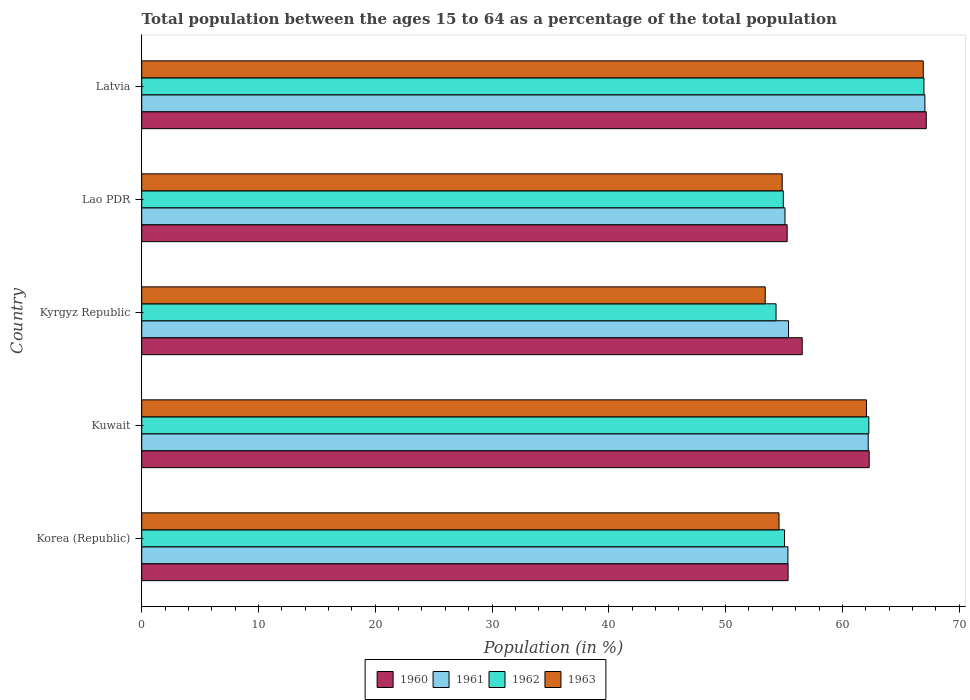How many groups of bars are there?
Provide a succinct answer. 5. How many bars are there on the 5th tick from the top?
Provide a short and direct response. 4. How many bars are there on the 5th tick from the bottom?
Offer a very short reply. 4. What is the label of the 1st group of bars from the top?
Keep it short and to the point. Latvia. In how many cases, is the number of bars for a given country not equal to the number of legend labels?
Your response must be concise. 0. What is the percentage of the population ages 15 to 64 in 1963 in Kuwait?
Provide a short and direct response. 62.06. Across all countries, what is the maximum percentage of the population ages 15 to 64 in 1960?
Ensure brevity in your answer.  67.18. Across all countries, what is the minimum percentage of the population ages 15 to 64 in 1960?
Your answer should be compact. 55.27. In which country was the percentage of the population ages 15 to 64 in 1960 maximum?
Give a very brief answer. Latvia. In which country was the percentage of the population ages 15 to 64 in 1962 minimum?
Provide a short and direct response. Kyrgyz Republic. What is the total percentage of the population ages 15 to 64 in 1961 in the graph?
Offer a terse response. 295.09. What is the difference between the percentage of the population ages 15 to 64 in 1962 in Korea (Republic) and that in Lao PDR?
Ensure brevity in your answer.  0.11. What is the difference between the percentage of the population ages 15 to 64 in 1960 in Lao PDR and the percentage of the population ages 15 to 64 in 1961 in Latvia?
Provide a short and direct response. -11.79. What is the average percentage of the population ages 15 to 64 in 1962 per country?
Provide a short and direct response. 58.71. What is the difference between the percentage of the population ages 15 to 64 in 1961 and percentage of the population ages 15 to 64 in 1963 in Korea (Republic)?
Ensure brevity in your answer.  0.76. In how many countries, is the percentage of the population ages 15 to 64 in 1960 greater than 8 ?
Provide a short and direct response. 5. What is the ratio of the percentage of the population ages 15 to 64 in 1962 in Korea (Republic) to that in Kyrgyz Republic?
Ensure brevity in your answer.  1.01. Is the percentage of the population ages 15 to 64 in 1961 in Kuwait less than that in Kyrgyz Republic?
Provide a succinct answer. No. What is the difference between the highest and the second highest percentage of the population ages 15 to 64 in 1963?
Your answer should be very brief. 4.86. What is the difference between the highest and the lowest percentage of the population ages 15 to 64 in 1962?
Offer a very short reply. 12.66. Is it the case that in every country, the sum of the percentage of the population ages 15 to 64 in 1963 and percentage of the population ages 15 to 64 in 1962 is greater than the sum of percentage of the population ages 15 to 64 in 1960 and percentage of the population ages 15 to 64 in 1961?
Keep it short and to the point. No. What does the 4th bar from the top in Latvia represents?
Ensure brevity in your answer.  1960. What does the 4th bar from the bottom in Korea (Republic) represents?
Ensure brevity in your answer.  1963. Is it the case that in every country, the sum of the percentage of the population ages 15 to 64 in 1963 and percentage of the population ages 15 to 64 in 1962 is greater than the percentage of the population ages 15 to 64 in 1961?
Offer a very short reply. Yes. Are the values on the major ticks of X-axis written in scientific E-notation?
Provide a succinct answer. No. Does the graph contain any zero values?
Offer a very short reply. No. Where does the legend appear in the graph?
Ensure brevity in your answer.  Bottom center. How many legend labels are there?
Your answer should be very brief. 4. How are the legend labels stacked?
Offer a very short reply. Horizontal. What is the title of the graph?
Provide a succinct answer. Total population between the ages 15 to 64 as a percentage of the total population. Does "2000" appear as one of the legend labels in the graph?
Offer a terse response. No. What is the label or title of the X-axis?
Keep it short and to the point. Population (in %). What is the label or title of the Y-axis?
Provide a succinct answer. Country. What is the Population (in %) in 1960 in Korea (Republic)?
Provide a short and direct response. 55.35. What is the Population (in %) of 1961 in Korea (Republic)?
Give a very brief answer. 55.34. What is the Population (in %) in 1962 in Korea (Republic)?
Your answer should be compact. 55.05. What is the Population (in %) of 1963 in Korea (Republic)?
Offer a terse response. 54.58. What is the Population (in %) of 1960 in Kuwait?
Offer a terse response. 62.3. What is the Population (in %) of 1961 in Kuwait?
Give a very brief answer. 62.21. What is the Population (in %) in 1962 in Kuwait?
Your answer should be very brief. 62.27. What is the Population (in %) in 1963 in Kuwait?
Your answer should be very brief. 62.06. What is the Population (in %) in 1960 in Kyrgyz Republic?
Provide a succinct answer. 56.56. What is the Population (in %) in 1961 in Kyrgyz Republic?
Provide a short and direct response. 55.39. What is the Population (in %) of 1962 in Kyrgyz Republic?
Give a very brief answer. 54.32. What is the Population (in %) in 1963 in Kyrgyz Republic?
Your response must be concise. 53.39. What is the Population (in %) of 1960 in Lao PDR?
Your response must be concise. 55.27. What is the Population (in %) of 1961 in Lao PDR?
Give a very brief answer. 55.09. What is the Population (in %) of 1962 in Lao PDR?
Ensure brevity in your answer.  54.94. What is the Population (in %) in 1963 in Lao PDR?
Make the answer very short. 54.84. What is the Population (in %) in 1960 in Latvia?
Offer a terse response. 67.18. What is the Population (in %) in 1961 in Latvia?
Your answer should be very brief. 67.06. What is the Population (in %) in 1962 in Latvia?
Keep it short and to the point. 66.99. What is the Population (in %) in 1963 in Latvia?
Provide a short and direct response. 66.93. Across all countries, what is the maximum Population (in %) of 1960?
Offer a very short reply. 67.18. Across all countries, what is the maximum Population (in %) in 1961?
Your response must be concise. 67.06. Across all countries, what is the maximum Population (in %) of 1962?
Your answer should be compact. 66.99. Across all countries, what is the maximum Population (in %) in 1963?
Keep it short and to the point. 66.93. Across all countries, what is the minimum Population (in %) of 1960?
Provide a succinct answer. 55.27. Across all countries, what is the minimum Population (in %) of 1961?
Your response must be concise. 55.09. Across all countries, what is the minimum Population (in %) of 1962?
Make the answer very short. 54.32. Across all countries, what is the minimum Population (in %) in 1963?
Offer a terse response. 53.39. What is the total Population (in %) in 1960 in the graph?
Ensure brevity in your answer.  296.66. What is the total Population (in %) in 1961 in the graph?
Give a very brief answer. 295.09. What is the total Population (in %) in 1962 in the graph?
Offer a terse response. 293.56. What is the total Population (in %) of 1963 in the graph?
Offer a very short reply. 291.8. What is the difference between the Population (in %) of 1960 in Korea (Republic) and that in Kuwait?
Keep it short and to the point. -6.95. What is the difference between the Population (in %) in 1961 in Korea (Republic) and that in Kuwait?
Your answer should be very brief. -6.88. What is the difference between the Population (in %) in 1962 in Korea (Republic) and that in Kuwait?
Offer a very short reply. -7.22. What is the difference between the Population (in %) of 1963 in Korea (Republic) and that in Kuwait?
Provide a short and direct response. -7.49. What is the difference between the Population (in %) of 1960 in Korea (Republic) and that in Kyrgyz Republic?
Keep it short and to the point. -1.21. What is the difference between the Population (in %) of 1961 in Korea (Republic) and that in Kyrgyz Republic?
Give a very brief answer. -0.05. What is the difference between the Population (in %) in 1962 in Korea (Republic) and that in Kyrgyz Republic?
Your answer should be compact. 0.73. What is the difference between the Population (in %) of 1963 in Korea (Republic) and that in Kyrgyz Republic?
Your answer should be very brief. 1.18. What is the difference between the Population (in %) in 1960 in Korea (Republic) and that in Lao PDR?
Your response must be concise. 0.08. What is the difference between the Population (in %) in 1961 in Korea (Republic) and that in Lao PDR?
Ensure brevity in your answer.  0.25. What is the difference between the Population (in %) in 1962 in Korea (Republic) and that in Lao PDR?
Keep it short and to the point. 0.11. What is the difference between the Population (in %) in 1963 in Korea (Republic) and that in Lao PDR?
Ensure brevity in your answer.  -0.27. What is the difference between the Population (in %) of 1960 in Korea (Republic) and that in Latvia?
Your answer should be very brief. -11.83. What is the difference between the Population (in %) in 1961 in Korea (Republic) and that in Latvia?
Your answer should be compact. -11.73. What is the difference between the Population (in %) of 1962 in Korea (Republic) and that in Latvia?
Your response must be concise. -11.94. What is the difference between the Population (in %) in 1963 in Korea (Republic) and that in Latvia?
Give a very brief answer. -12.35. What is the difference between the Population (in %) of 1960 in Kuwait and that in Kyrgyz Republic?
Keep it short and to the point. 5.74. What is the difference between the Population (in %) of 1961 in Kuwait and that in Kyrgyz Republic?
Give a very brief answer. 6.82. What is the difference between the Population (in %) of 1962 in Kuwait and that in Kyrgyz Republic?
Make the answer very short. 7.95. What is the difference between the Population (in %) in 1963 in Kuwait and that in Kyrgyz Republic?
Offer a very short reply. 8.67. What is the difference between the Population (in %) in 1960 in Kuwait and that in Lao PDR?
Make the answer very short. 7.03. What is the difference between the Population (in %) of 1961 in Kuwait and that in Lao PDR?
Ensure brevity in your answer.  7.13. What is the difference between the Population (in %) of 1962 in Kuwait and that in Lao PDR?
Make the answer very short. 7.33. What is the difference between the Population (in %) of 1963 in Kuwait and that in Lao PDR?
Ensure brevity in your answer.  7.22. What is the difference between the Population (in %) in 1960 in Kuwait and that in Latvia?
Your answer should be very brief. -4.89. What is the difference between the Population (in %) in 1961 in Kuwait and that in Latvia?
Offer a very short reply. -4.85. What is the difference between the Population (in %) in 1962 in Kuwait and that in Latvia?
Keep it short and to the point. -4.72. What is the difference between the Population (in %) in 1963 in Kuwait and that in Latvia?
Your answer should be very brief. -4.86. What is the difference between the Population (in %) in 1960 in Kyrgyz Republic and that in Lao PDR?
Make the answer very short. 1.29. What is the difference between the Population (in %) of 1961 in Kyrgyz Republic and that in Lao PDR?
Keep it short and to the point. 0.3. What is the difference between the Population (in %) in 1962 in Kyrgyz Republic and that in Lao PDR?
Ensure brevity in your answer.  -0.62. What is the difference between the Population (in %) in 1963 in Kyrgyz Republic and that in Lao PDR?
Provide a short and direct response. -1.45. What is the difference between the Population (in %) in 1960 in Kyrgyz Republic and that in Latvia?
Ensure brevity in your answer.  -10.62. What is the difference between the Population (in %) of 1961 in Kyrgyz Republic and that in Latvia?
Provide a short and direct response. -11.68. What is the difference between the Population (in %) in 1962 in Kyrgyz Republic and that in Latvia?
Provide a short and direct response. -12.66. What is the difference between the Population (in %) of 1963 in Kyrgyz Republic and that in Latvia?
Ensure brevity in your answer.  -13.53. What is the difference between the Population (in %) of 1960 in Lao PDR and that in Latvia?
Offer a terse response. -11.91. What is the difference between the Population (in %) in 1961 in Lao PDR and that in Latvia?
Offer a terse response. -11.98. What is the difference between the Population (in %) of 1962 in Lao PDR and that in Latvia?
Your response must be concise. -12.04. What is the difference between the Population (in %) of 1963 in Lao PDR and that in Latvia?
Your answer should be very brief. -12.08. What is the difference between the Population (in %) of 1960 in Korea (Republic) and the Population (in %) of 1961 in Kuwait?
Offer a very short reply. -6.86. What is the difference between the Population (in %) in 1960 in Korea (Republic) and the Population (in %) in 1962 in Kuwait?
Keep it short and to the point. -6.92. What is the difference between the Population (in %) of 1960 in Korea (Republic) and the Population (in %) of 1963 in Kuwait?
Keep it short and to the point. -6.71. What is the difference between the Population (in %) of 1961 in Korea (Republic) and the Population (in %) of 1962 in Kuwait?
Provide a short and direct response. -6.93. What is the difference between the Population (in %) in 1961 in Korea (Republic) and the Population (in %) in 1963 in Kuwait?
Your answer should be very brief. -6.73. What is the difference between the Population (in %) of 1962 in Korea (Republic) and the Population (in %) of 1963 in Kuwait?
Your answer should be compact. -7.02. What is the difference between the Population (in %) in 1960 in Korea (Republic) and the Population (in %) in 1961 in Kyrgyz Republic?
Ensure brevity in your answer.  -0.04. What is the difference between the Population (in %) of 1960 in Korea (Republic) and the Population (in %) of 1962 in Kyrgyz Republic?
Provide a short and direct response. 1.03. What is the difference between the Population (in %) of 1960 in Korea (Republic) and the Population (in %) of 1963 in Kyrgyz Republic?
Your answer should be compact. 1.96. What is the difference between the Population (in %) in 1961 in Korea (Republic) and the Population (in %) in 1962 in Kyrgyz Republic?
Keep it short and to the point. 1.02. What is the difference between the Population (in %) of 1961 in Korea (Republic) and the Population (in %) of 1963 in Kyrgyz Republic?
Ensure brevity in your answer.  1.94. What is the difference between the Population (in %) in 1962 in Korea (Republic) and the Population (in %) in 1963 in Kyrgyz Republic?
Give a very brief answer. 1.65. What is the difference between the Population (in %) in 1960 in Korea (Republic) and the Population (in %) in 1961 in Lao PDR?
Your response must be concise. 0.27. What is the difference between the Population (in %) in 1960 in Korea (Republic) and the Population (in %) in 1962 in Lao PDR?
Your answer should be very brief. 0.41. What is the difference between the Population (in %) in 1960 in Korea (Republic) and the Population (in %) in 1963 in Lao PDR?
Offer a very short reply. 0.51. What is the difference between the Population (in %) of 1961 in Korea (Republic) and the Population (in %) of 1962 in Lao PDR?
Offer a very short reply. 0.4. What is the difference between the Population (in %) of 1961 in Korea (Republic) and the Population (in %) of 1963 in Lao PDR?
Provide a succinct answer. 0.49. What is the difference between the Population (in %) of 1962 in Korea (Republic) and the Population (in %) of 1963 in Lao PDR?
Provide a succinct answer. 0.2. What is the difference between the Population (in %) in 1960 in Korea (Republic) and the Population (in %) in 1961 in Latvia?
Give a very brief answer. -11.71. What is the difference between the Population (in %) of 1960 in Korea (Republic) and the Population (in %) of 1962 in Latvia?
Offer a terse response. -11.63. What is the difference between the Population (in %) of 1960 in Korea (Republic) and the Population (in %) of 1963 in Latvia?
Your answer should be compact. -11.58. What is the difference between the Population (in %) in 1961 in Korea (Republic) and the Population (in %) in 1962 in Latvia?
Give a very brief answer. -11.65. What is the difference between the Population (in %) of 1961 in Korea (Republic) and the Population (in %) of 1963 in Latvia?
Give a very brief answer. -11.59. What is the difference between the Population (in %) of 1962 in Korea (Republic) and the Population (in %) of 1963 in Latvia?
Your response must be concise. -11.88. What is the difference between the Population (in %) of 1960 in Kuwait and the Population (in %) of 1961 in Kyrgyz Republic?
Give a very brief answer. 6.91. What is the difference between the Population (in %) in 1960 in Kuwait and the Population (in %) in 1962 in Kyrgyz Republic?
Offer a very short reply. 7.98. What is the difference between the Population (in %) of 1960 in Kuwait and the Population (in %) of 1963 in Kyrgyz Republic?
Your response must be concise. 8.9. What is the difference between the Population (in %) in 1961 in Kuwait and the Population (in %) in 1962 in Kyrgyz Republic?
Your answer should be compact. 7.89. What is the difference between the Population (in %) of 1961 in Kuwait and the Population (in %) of 1963 in Kyrgyz Republic?
Offer a terse response. 8.82. What is the difference between the Population (in %) of 1962 in Kuwait and the Population (in %) of 1963 in Kyrgyz Republic?
Provide a succinct answer. 8.87. What is the difference between the Population (in %) of 1960 in Kuwait and the Population (in %) of 1961 in Lao PDR?
Offer a very short reply. 7.21. What is the difference between the Population (in %) in 1960 in Kuwait and the Population (in %) in 1962 in Lao PDR?
Provide a short and direct response. 7.36. What is the difference between the Population (in %) of 1960 in Kuwait and the Population (in %) of 1963 in Lao PDR?
Make the answer very short. 7.45. What is the difference between the Population (in %) of 1961 in Kuwait and the Population (in %) of 1962 in Lao PDR?
Offer a very short reply. 7.27. What is the difference between the Population (in %) in 1961 in Kuwait and the Population (in %) in 1963 in Lao PDR?
Give a very brief answer. 7.37. What is the difference between the Population (in %) of 1962 in Kuwait and the Population (in %) of 1963 in Lao PDR?
Provide a succinct answer. 7.42. What is the difference between the Population (in %) in 1960 in Kuwait and the Population (in %) in 1961 in Latvia?
Your response must be concise. -4.77. What is the difference between the Population (in %) of 1960 in Kuwait and the Population (in %) of 1962 in Latvia?
Ensure brevity in your answer.  -4.69. What is the difference between the Population (in %) in 1960 in Kuwait and the Population (in %) in 1963 in Latvia?
Keep it short and to the point. -4.63. What is the difference between the Population (in %) of 1961 in Kuwait and the Population (in %) of 1962 in Latvia?
Offer a terse response. -4.77. What is the difference between the Population (in %) in 1961 in Kuwait and the Population (in %) in 1963 in Latvia?
Your answer should be compact. -4.71. What is the difference between the Population (in %) of 1962 in Kuwait and the Population (in %) of 1963 in Latvia?
Your response must be concise. -4.66. What is the difference between the Population (in %) in 1960 in Kyrgyz Republic and the Population (in %) in 1961 in Lao PDR?
Offer a very short reply. 1.48. What is the difference between the Population (in %) of 1960 in Kyrgyz Republic and the Population (in %) of 1962 in Lao PDR?
Your answer should be compact. 1.62. What is the difference between the Population (in %) of 1960 in Kyrgyz Republic and the Population (in %) of 1963 in Lao PDR?
Your answer should be very brief. 1.72. What is the difference between the Population (in %) in 1961 in Kyrgyz Republic and the Population (in %) in 1962 in Lao PDR?
Offer a terse response. 0.45. What is the difference between the Population (in %) in 1961 in Kyrgyz Republic and the Population (in %) in 1963 in Lao PDR?
Provide a succinct answer. 0.54. What is the difference between the Population (in %) of 1962 in Kyrgyz Republic and the Population (in %) of 1963 in Lao PDR?
Provide a succinct answer. -0.52. What is the difference between the Population (in %) in 1960 in Kyrgyz Republic and the Population (in %) in 1961 in Latvia?
Offer a terse response. -10.5. What is the difference between the Population (in %) of 1960 in Kyrgyz Republic and the Population (in %) of 1962 in Latvia?
Ensure brevity in your answer.  -10.42. What is the difference between the Population (in %) in 1960 in Kyrgyz Republic and the Population (in %) in 1963 in Latvia?
Offer a very short reply. -10.37. What is the difference between the Population (in %) in 1961 in Kyrgyz Republic and the Population (in %) in 1962 in Latvia?
Offer a terse response. -11.6. What is the difference between the Population (in %) of 1961 in Kyrgyz Republic and the Population (in %) of 1963 in Latvia?
Your response must be concise. -11.54. What is the difference between the Population (in %) of 1962 in Kyrgyz Republic and the Population (in %) of 1963 in Latvia?
Provide a succinct answer. -12.61. What is the difference between the Population (in %) in 1960 in Lao PDR and the Population (in %) in 1961 in Latvia?
Ensure brevity in your answer.  -11.79. What is the difference between the Population (in %) in 1960 in Lao PDR and the Population (in %) in 1962 in Latvia?
Provide a short and direct response. -11.71. What is the difference between the Population (in %) in 1960 in Lao PDR and the Population (in %) in 1963 in Latvia?
Keep it short and to the point. -11.66. What is the difference between the Population (in %) of 1961 in Lao PDR and the Population (in %) of 1962 in Latvia?
Give a very brief answer. -11.9. What is the difference between the Population (in %) of 1961 in Lao PDR and the Population (in %) of 1963 in Latvia?
Provide a short and direct response. -11.84. What is the difference between the Population (in %) in 1962 in Lao PDR and the Population (in %) in 1963 in Latvia?
Give a very brief answer. -11.99. What is the average Population (in %) in 1960 per country?
Offer a terse response. 59.33. What is the average Population (in %) of 1961 per country?
Keep it short and to the point. 59.02. What is the average Population (in %) of 1962 per country?
Your answer should be compact. 58.71. What is the average Population (in %) in 1963 per country?
Make the answer very short. 58.36. What is the difference between the Population (in %) of 1960 and Population (in %) of 1961 in Korea (Republic)?
Your answer should be very brief. 0.01. What is the difference between the Population (in %) of 1960 and Population (in %) of 1962 in Korea (Republic)?
Ensure brevity in your answer.  0.3. What is the difference between the Population (in %) of 1960 and Population (in %) of 1963 in Korea (Republic)?
Provide a succinct answer. 0.78. What is the difference between the Population (in %) of 1961 and Population (in %) of 1962 in Korea (Republic)?
Offer a terse response. 0.29. What is the difference between the Population (in %) in 1961 and Population (in %) in 1963 in Korea (Republic)?
Ensure brevity in your answer.  0.76. What is the difference between the Population (in %) in 1962 and Population (in %) in 1963 in Korea (Republic)?
Ensure brevity in your answer.  0.47. What is the difference between the Population (in %) of 1960 and Population (in %) of 1961 in Kuwait?
Your answer should be very brief. 0.08. What is the difference between the Population (in %) of 1960 and Population (in %) of 1962 in Kuwait?
Give a very brief answer. 0.03. What is the difference between the Population (in %) in 1960 and Population (in %) in 1963 in Kuwait?
Ensure brevity in your answer.  0.23. What is the difference between the Population (in %) in 1961 and Population (in %) in 1962 in Kuwait?
Make the answer very short. -0.05. What is the difference between the Population (in %) in 1961 and Population (in %) in 1963 in Kuwait?
Provide a succinct answer. 0.15. What is the difference between the Population (in %) in 1962 and Population (in %) in 1963 in Kuwait?
Offer a very short reply. 0.2. What is the difference between the Population (in %) in 1960 and Population (in %) in 1961 in Kyrgyz Republic?
Offer a very short reply. 1.17. What is the difference between the Population (in %) of 1960 and Population (in %) of 1962 in Kyrgyz Republic?
Your response must be concise. 2.24. What is the difference between the Population (in %) in 1960 and Population (in %) in 1963 in Kyrgyz Republic?
Ensure brevity in your answer.  3.17. What is the difference between the Population (in %) in 1961 and Population (in %) in 1962 in Kyrgyz Republic?
Offer a very short reply. 1.07. What is the difference between the Population (in %) in 1961 and Population (in %) in 1963 in Kyrgyz Republic?
Make the answer very short. 2. What is the difference between the Population (in %) of 1962 and Population (in %) of 1963 in Kyrgyz Republic?
Offer a terse response. 0.93. What is the difference between the Population (in %) in 1960 and Population (in %) in 1961 in Lao PDR?
Provide a succinct answer. 0.19. What is the difference between the Population (in %) in 1960 and Population (in %) in 1962 in Lao PDR?
Your answer should be very brief. 0.33. What is the difference between the Population (in %) of 1960 and Population (in %) of 1963 in Lao PDR?
Offer a terse response. 0.43. What is the difference between the Population (in %) in 1961 and Population (in %) in 1962 in Lao PDR?
Your answer should be very brief. 0.14. What is the difference between the Population (in %) of 1961 and Population (in %) of 1963 in Lao PDR?
Offer a very short reply. 0.24. What is the difference between the Population (in %) of 1962 and Population (in %) of 1963 in Lao PDR?
Make the answer very short. 0.1. What is the difference between the Population (in %) of 1960 and Population (in %) of 1961 in Latvia?
Your answer should be very brief. 0.12. What is the difference between the Population (in %) of 1960 and Population (in %) of 1962 in Latvia?
Give a very brief answer. 0.2. What is the difference between the Population (in %) of 1960 and Population (in %) of 1963 in Latvia?
Provide a short and direct response. 0.26. What is the difference between the Population (in %) of 1961 and Population (in %) of 1962 in Latvia?
Offer a terse response. 0.08. What is the difference between the Population (in %) in 1961 and Population (in %) in 1963 in Latvia?
Your answer should be very brief. 0.14. What is the difference between the Population (in %) in 1962 and Population (in %) in 1963 in Latvia?
Your answer should be very brief. 0.06. What is the ratio of the Population (in %) of 1960 in Korea (Republic) to that in Kuwait?
Offer a very short reply. 0.89. What is the ratio of the Population (in %) of 1961 in Korea (Republic) to that in Kuwait?
Your answer should be very brief. 0.89. What is the ratio of the Population (in %) in 1962 in Korea (Republic) to that in Kuwait?
Your answer should be compact. 0.88. What is the ratio of the Population (in %) in 1963 in Korea (Republic) to that in Kuwait?
Make the answer very short. 0.88. What is the ratio of the Population (in %) in 1960 in Korea (Republic) to that in Kyrgyz Republic?
Make the answer very short. 0.98. What is the ratio of the Population (in %) of 1962 in Korea (Republic) to that in Kyrgyz Republic?
Offer a very short reply. 1.01. What is the ratio of the Population (in %) of 1963 in Korea (Republic) to that in Kyrgyz Republic?
Offer a very short reply. 1.02. What is the ratio of the Population (in %) of 1960 in Korea (Republic) to that in Lao PDR?
Keep it short and to the point. 1. What is the ratio of the Population (in %) of 1960 in Korea (Republic) to that in Latvia?
Provide a succinct answer. 0.82. What is the ratio of the Population (in %) in 1961 in Korea (Republic) to that in Latvia?
Provide a short and direct response. 0.83. What is the ratio of the Population (in %) of 1962 in Korea (Republic) to that in Latvia?
Ensure brevity in your answer.  0.82. What is the ratio of the Population (in %) of 1963 in Korea (Republic) to that in Latvia?
Provide a short and direct response. 0.82. What is the ratio of the Population (in %) in 1960 in Kuwait to that in Kyrgyz Republic?
Offer a terse response. 1.1. What is the ratio of the Population (in %) in 1961 in Kuwait to that in Kyrgyz Republic?
Provide a succinct answer. 1.12. What is the ratio of the Population (in %) of 1962 in Kuwait to that in Kyrgyz Republic?
Your answer should be very brief. 1.15. What is the ratio of the Population (in %) of 1963 in Kuwait to that in Kyrgyz Republic?
Your answer should be compact. 1.16. What is the ratio of the Population (in %) of 1960 in Kuwait to that in Lao PDR?
Keep it short and to the point. 1.13. What is the ratio of the Population (in %) in 1961 in Kuwait to that in Lao PDR?
Give a very brief answer. 1.13. What is the ratio of the Population (in %) in 1962 in Kuwait to that in Lao PDR?
Ensure brevity in your answer.  1.13. What is the ratio of the Population (in %) in 1963 in Kuwait to that in Lao PDR?
Your response must be concise. 1.13. What is the ratio of the Population (in %) of 1960 in Kuwait to that in Latvia?
Give a very brief answer. 0.93. What is the ratio of the Population (in %) of 1961 in Kuwait to that in Latvia?
Offer a very short reply. 0.93. What is the ratio of the Population (in %) in 1962 in Kuwait to that in Latvia?
Give a very brief answer. 0.93. What is the ratio of the Population (in %) in 1963 in Kuwait to that in Latvia?
Keep it short and to the point. 0.93. What is the ratio of the Population (in %) of 1960 in Kyrgyz Republic to that in Lao PDR?
Ensure brevity in your answer.  1.02. What is the ratio of the Population (in %) of 1962 in Kyrgyz Republic to that in Lao PDR?
Give a very brief answer. 0.99. What is the ratio of the Population (in %) in 1963 in Kyrgyz Republic to that in Lao PDR?
Keep it short and to the point. 0.97. What is the ratio of the Population (in %) of 1960 in Kyrgyz Republic to that in Latvia?
Offer a terse response. 0.84. What is the ratio of the Population (in %) of 1961 in Kyrgyz Republic to that in Latvia?
Offer a terse response. 0.83. What is the ratio of the Population (in %) of 1962 in Kyrgyz Republic to that in Latvia?
Your response must be concise. 0.81. What is the ratio of the Population (in %) in 1963 in Kyrgyz Republic to that in Latvia?
Your answer should be very brief. 0.8. What is the ratio of the Population (in %) in 1960 in Lao PDR to that in Latvia?
Keep it short and to the point. 0.82. What is the ratio of the Population (in %) of 1961 in Lao PDR to that in Latvia?
Make the answer very short. 0.82. What is the ratio of the Population (in %) in 1962 in Lao PDR to that in Latvia?
Your answer should be very brief. 0.82. What is the ratio of the Population (in %) of 1963 in Lao PDR to that in Latvia?
Ensure brevity in your answer.  0.82. What is the difference between the highest and the second highest Population (in %) in 1960?
Give a very brief answer. 4.89. What is the difference between the highest and the second highest Population (in %) in 1961?
Offer a very short reply. 4.85. What is the difference between the highest and the second highest Population (in %) of 1962?
Your answer should be compact. 4.72. What is the difference between the highest and the second highest Population (in %) in 1963?
Ensure brevity in your answer.  4.86. What is the difference between the highest and the lowest Population (in %) in 1960?
Your response must be concise. 11.91. What is the difference between the highest and the lowest Population (in %) of 1961?
Make the answer very short. 11.98. What is the difference between the highest and the lowest Population (in %) in 1962?
Provide a short and direct response. 12.66. What is the difference between the highest and the lowest Population (in %) in 1963?
Make the answer very short. 13.53. 